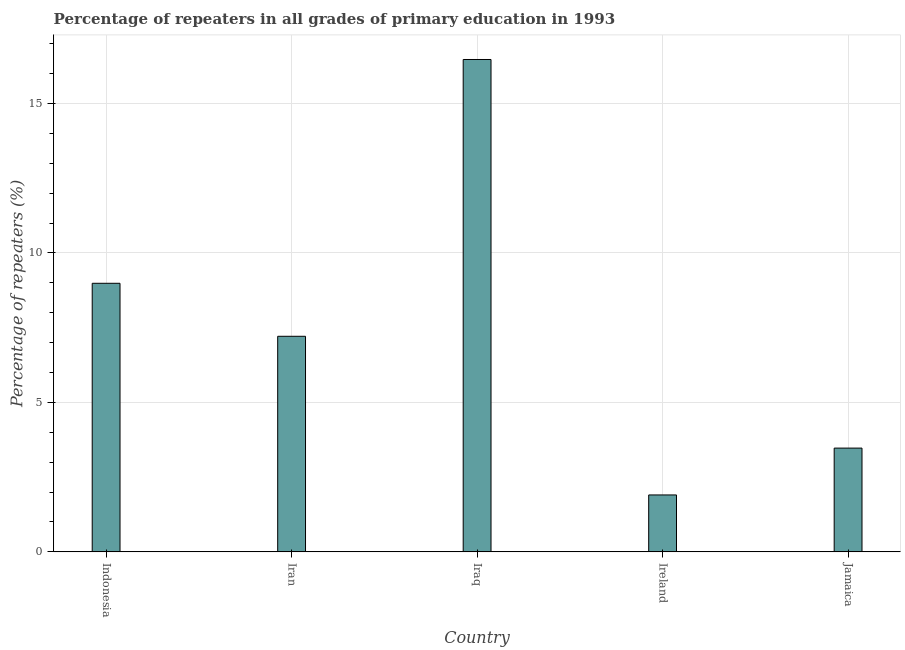What is the title of the graph?
Offer a terse response. Percentage of repeaters in all grades of primary education in 1993. What is the label or title of the Y-axis?
Your answer should be very brief. Percentage of repeaters (%). What is the percentage of repeaters in primary education in Indonesia?
Your response must be concise. 8.99. Across all countries, what is the maximum percentage of repeaters in primary education?
Give a very brief answer. 16.47. Across all countries, what is the minimum percentage of repeaters in primary education?
Your response must be concise. 1.9. In which country was the percentage of repeaters in primary education maximum?
Keep it short and to the point. Iraq. In which country was the percentage of repeaters in primary education minimum?
Offer a very short reply. Ireland. What is the sum of the percentage of repeaters in primary education?
Provide a succinct answer. 38.05. What is the difference between the percentage of repeaters in primary education in Indonesia and Ireland?
Give a very brief answer. 7.08. What is the average percentage of repeaters in primary education per country?
Provide a short and direct response. 7.61. What is the median percentage of repeaters in primary education?
Your answer should be compact. 7.21. In how many countries, is the percentage of repeaters in primary education greater than 14 %?
Offer a terse response. 1. What is the ratio of the percentage of repeaters in primary education in Indonesia to that in Jamaica?
Keep it short and to the point. 2.59. Is the percentage of repeaters in primary education in Indonesia less than that in Iran?
Keep it short and to the point. No. What is the difference between the highest and the second highest percentage of repeaters in primary education?
Keep it short and to the point. 7.49. What is the difference between the highest and the lowest percentage of repeaters in primary education?
Offer a terse response. 14.57. In how many countries, is the percentage of repeaters in primary education greater than the average percentage of repeaters in primary education taken over all countries?
Your response must be concise. 2. How many bars are there?
Your response must be concise. 5. Are all the bars in the graph horizontal?
Offer a terse response. No. What is the difference between two consecutive major ticks on the Y-axis?
Provide a succinct answer. 5. What is the Percentage of repeaters (%) in Indonesia?
Your answer should be very brief. 8.99. What is the Percentage of repeaters (%) in Iran?
Your answer should be compact. 7.21. What is the Percentage of repeaters (%) in Iraq?
Give a very brief answer. 16.47. What is the Percentage of repeaters (%) of Ireland?
Provide a succinct answer. 1.9. What is the Percentage of repeaters (%) in Jamaica?
Provide a succinct answer. 3.47. What is the difference between the Percentage of repeaters (%) in Indonesia and Iran?
Your answer should be compact. 1.77. What is the difference between the Percentage of repeaters (%) in Indonesia and Iraq?
Provide a succinct answer. -7.49. What is the difference between the Percentage of repeaters (%) in Indonesia and Ireland?
Keep it short and to the point. 7.08. What is the difference between the Percentage of repeaters (%) in Indonesia and Jamaica?
Give a very brief answer. 5.51. What is the difference between the Percentage of repeaters (%) in Iran and Iraq?
Offer a terse response. -9.26. What is the difference between the Percentage of repeaters (%) in Iran and Ireland?
Provide a succinct answer. 5.31. What is the difference between the Percentage of repeaters (%) in Iran and Jamaica?
Your answer should be very brief. 3.74. What is the difference between the Percentage of repeaters (%) in Iraq and Ireland?
Ensure brevity in your answer.  14.57. What is the difference between the Percentage of repeaters (%) in Iraq and Jamaica?
Give a very brief answer. 13. What is the difference between the Percentage of repeaters (%) in Ireland and Jamaica?
Give a very brief answer. -1.57. What is the ratio of the Percentage of repeaters (%) in Indonesia to that in Iran?
Make the answer very short. 1.25. What is the ratio of the Percentage of repeaters (%) in Indonesia to that in Iraq?
Give a very brief answer. 0.55. What is the ratio of the Percentage of repeaters (%) in Indonesia to that in Ireland?
Your answer should be very brief. 4.72. What is the ratio of the Percentage of repeaters (%) in Indonesia to that in Jamaica?
Your answer should be very brief. 2.59. What is the ratio of the Percentage of repeaters (%) in Iran to that in Iraq?
Offer a very short reply. 0.44. What is the ratio of the Percentage of repeaters (%) in Iran to that in Ireland?
Make the answer very short. 3.79. What is the ratio of the Percentage of repeaters (%) in Iran to that in Jamaica?
Offer a terse response. 2.08. What is the ratio of the Percentage of repeaters (%) in Iraq to that in Ireland?
Provide a short and direct response. 8.65. What is the ratio of the Percentage of repeaters (%) in Iraq to that in Jamaica?
Keep it short and to the point. 4.74. What is the ratio of the Percentage of repeaters (%) in Ireland to that in Jamaica?
Your answer should be very brief. 0.55. 